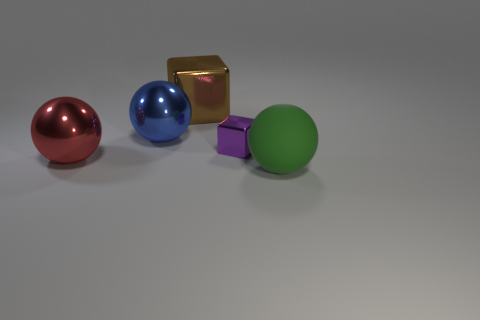Add 3 rubber balls. How many objects exist? 8 Subtract all cubes. How many objects are left? 3 Add 4 green objects. How many green objects exist? 5 Subtract 0 cyan cylinders. How many objects are left? 5 Subtract all green blocks. Subtract all purple metal objects. How many objects are left? 4 Add 5 blue objects. How many blue objects are left? 6 